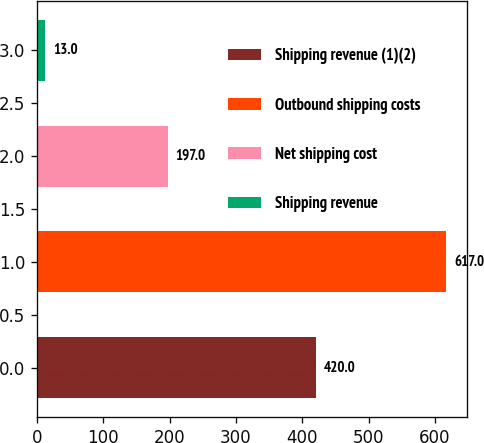<chart> <loc_0><loc_0><loc_500><loc_500><bar_chart><fcel>Shipping revenue (1)(2)<fcel>Outbound shipping costs<fcel>Net shipping cost<fcel>Shipping revenue<nl><fcel>420<fcel>617<fcel>197<fcel>13<nl></chart> 